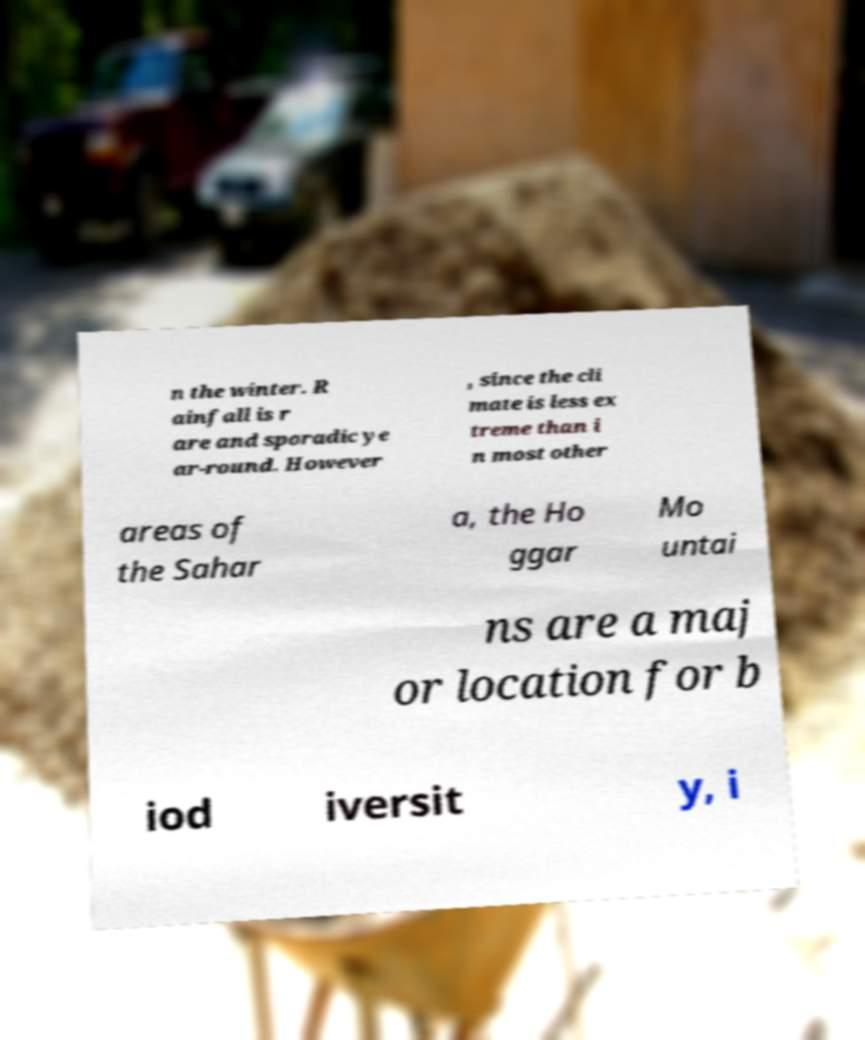There's text embedded in this image that I need extracted. Can you transcribe it verbatim? n the winter. R ainfall is r are and sporadic ye ar-round. However , since the cli mate is less ex treme than i n most other areas of the Sahar a, the Ho ggar Mo untai ns are a maj or location for b iod iversit y, i 